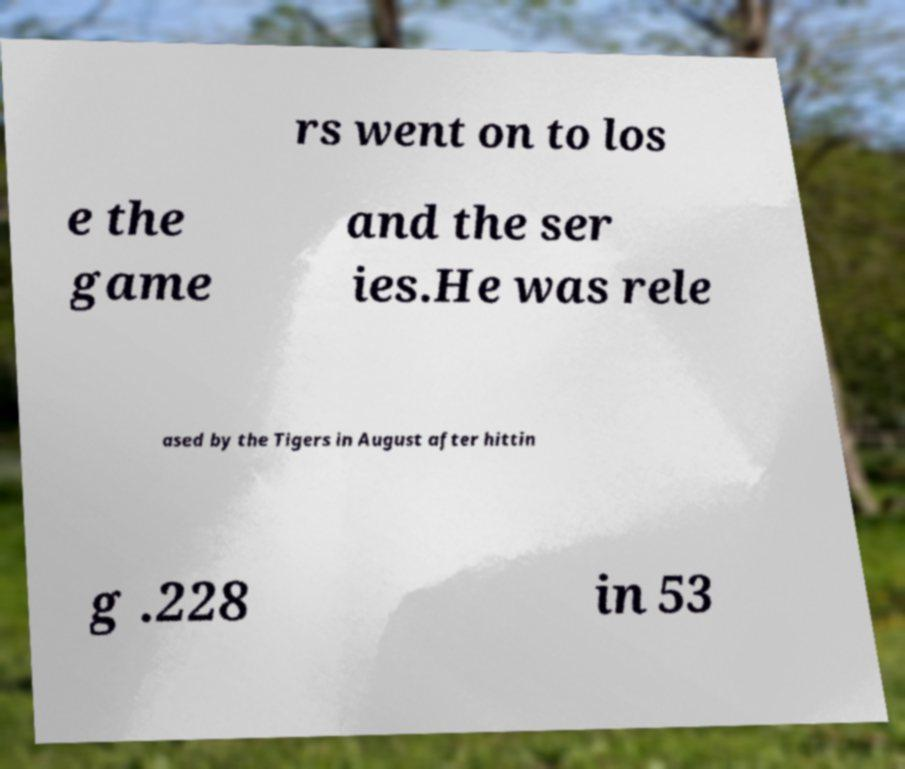Can you accurately transcribe the text from the provided image for me? rs went on to los e the game and the ser ies.He was rele ased by the Tigers in August after hittin g .228 in 53 